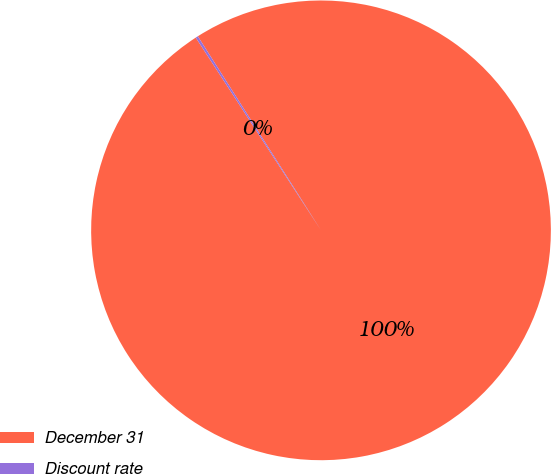<chart> <loc_0><loc_0><loc_500><loc_500><pie_chart><fcel>December 31<fcel>Discount rate<nl><fcel>99.83%<fcel>0.17%<nl></chart> 